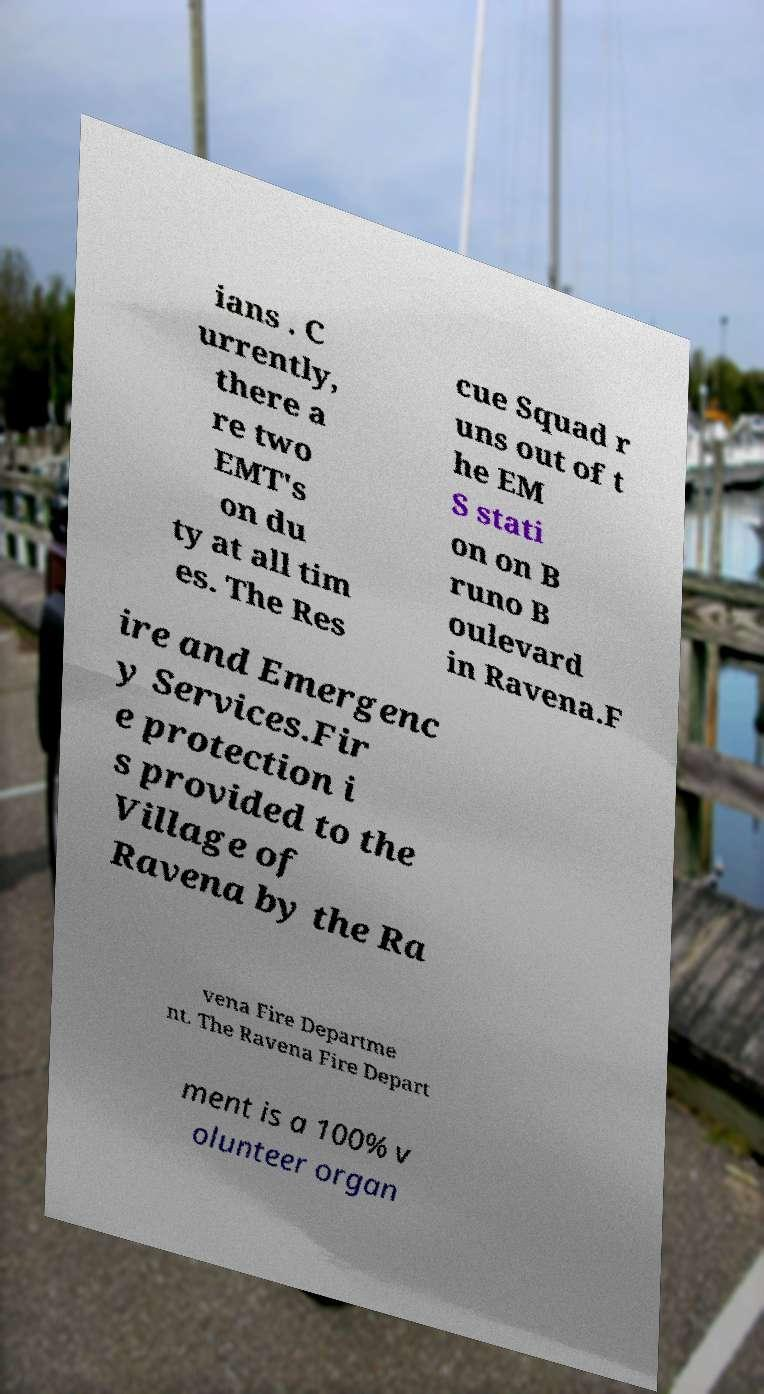What messages or text are displayed in this image? I need them in a readable, typed format. ians . C urrently, there a re two EMT's on du ty at all tim es. The Res cue Squad r uns out of t he EM S stati on on B runo B oulevard in Ravena.F ire and Emergenc y Services.Fir e protection i s provided to the Village of Ravena by the Ra vena Fire Departme nt. The Ravena Fire Depart ment is a 100% v olunteer organ 